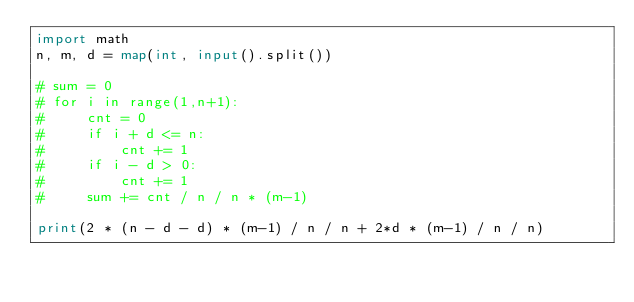Convert code to text. <code><loc_0><loc_0><loc_500><loc_500><_Python_>import math
n, m, d = map(int, input().split())

# sum = 0
# for i in range(1,n+1):
#     cnt = 0
#     if i + d <= n:
#         cnt += 1
#     if i - d > 0:
#         cnt += 1
#     sum += cnt / n / n * (m-1)

print(2 * (n - d - d) * (m-1) / n / n + 2*d * (m-1) / n / n)</code> 